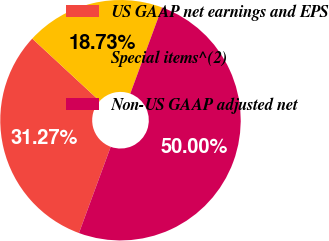Convert chart to OTSL. <chart><loc_0><loc_0><loc_500><loc_500><pie_chart><fcel>US GAAP net earnings and EPS<fcel>Special items^(2)<fcel>Non-US GAAP adjusted net<nl><fcel>31.27%<fcel>18.73%<fcel>50.0%<nl></chart> 